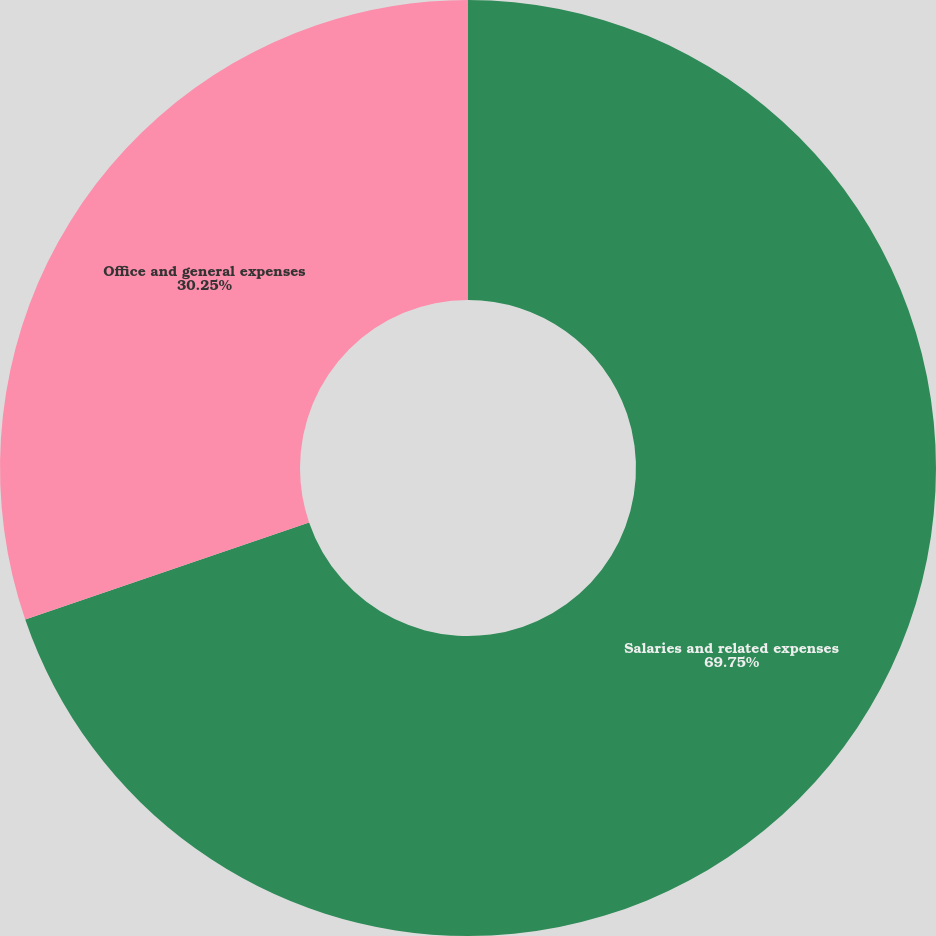Convert chart to OTSL. <chart><loc_0><loc_0><loc_500><loc_500><pie_chart><fcel>Salaries and related expenses<fcel>Office and general expenses<nl><fcel>69.75%<fcel>30.25%<nl></chart> 